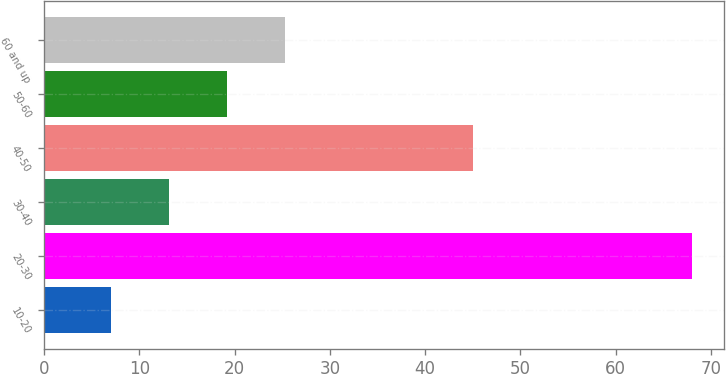<chart> <loc_0><loc_0><loc_500><loc_500><bar_chart><fcel>10-20<fcel>20-30<fcel>30-40<fcel>40-50<fcel>50-60<fcel>60 and up<nl><fcel>7<fcel>68<fcel>13.1<fcel>45<fcel>19.2<fcel>25.3<nl></chart> 